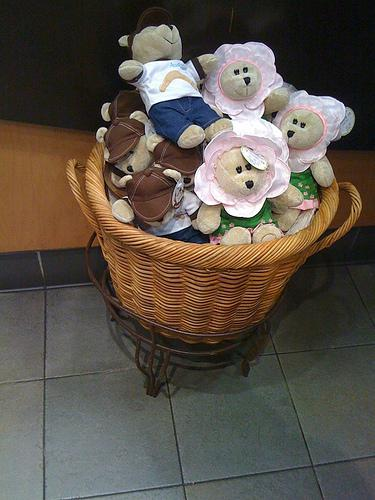Question: what color are the dresses?
Choices:
A. Green.
B. Red.
C. White.
D. Black.
Answer with the letter. Answer: A Question: how many stuffed bears are in the basket?
Choices:
A. Four.
B. Five.
C. Eight.
D. Six.
Answer with the letter. Answer: C Question: what stuffed animal is in the basket?
Choices:
A. A cat.
B. A dog.
C. A bear.
D. A lion.
Answer with the letter. Answer: C Question: where are the stuffed bears?
Choices:
A. In a basket.
B. On the bed.
C. On the gorund.
D. On a table.
Answer with the letter. Answer: A Question: what do the bears on the right on their heads?
Choices:
A. A weed.
B. A bushel.
C. A piece of grain.
D. A flower.
Answer with the letter. Answer: D 